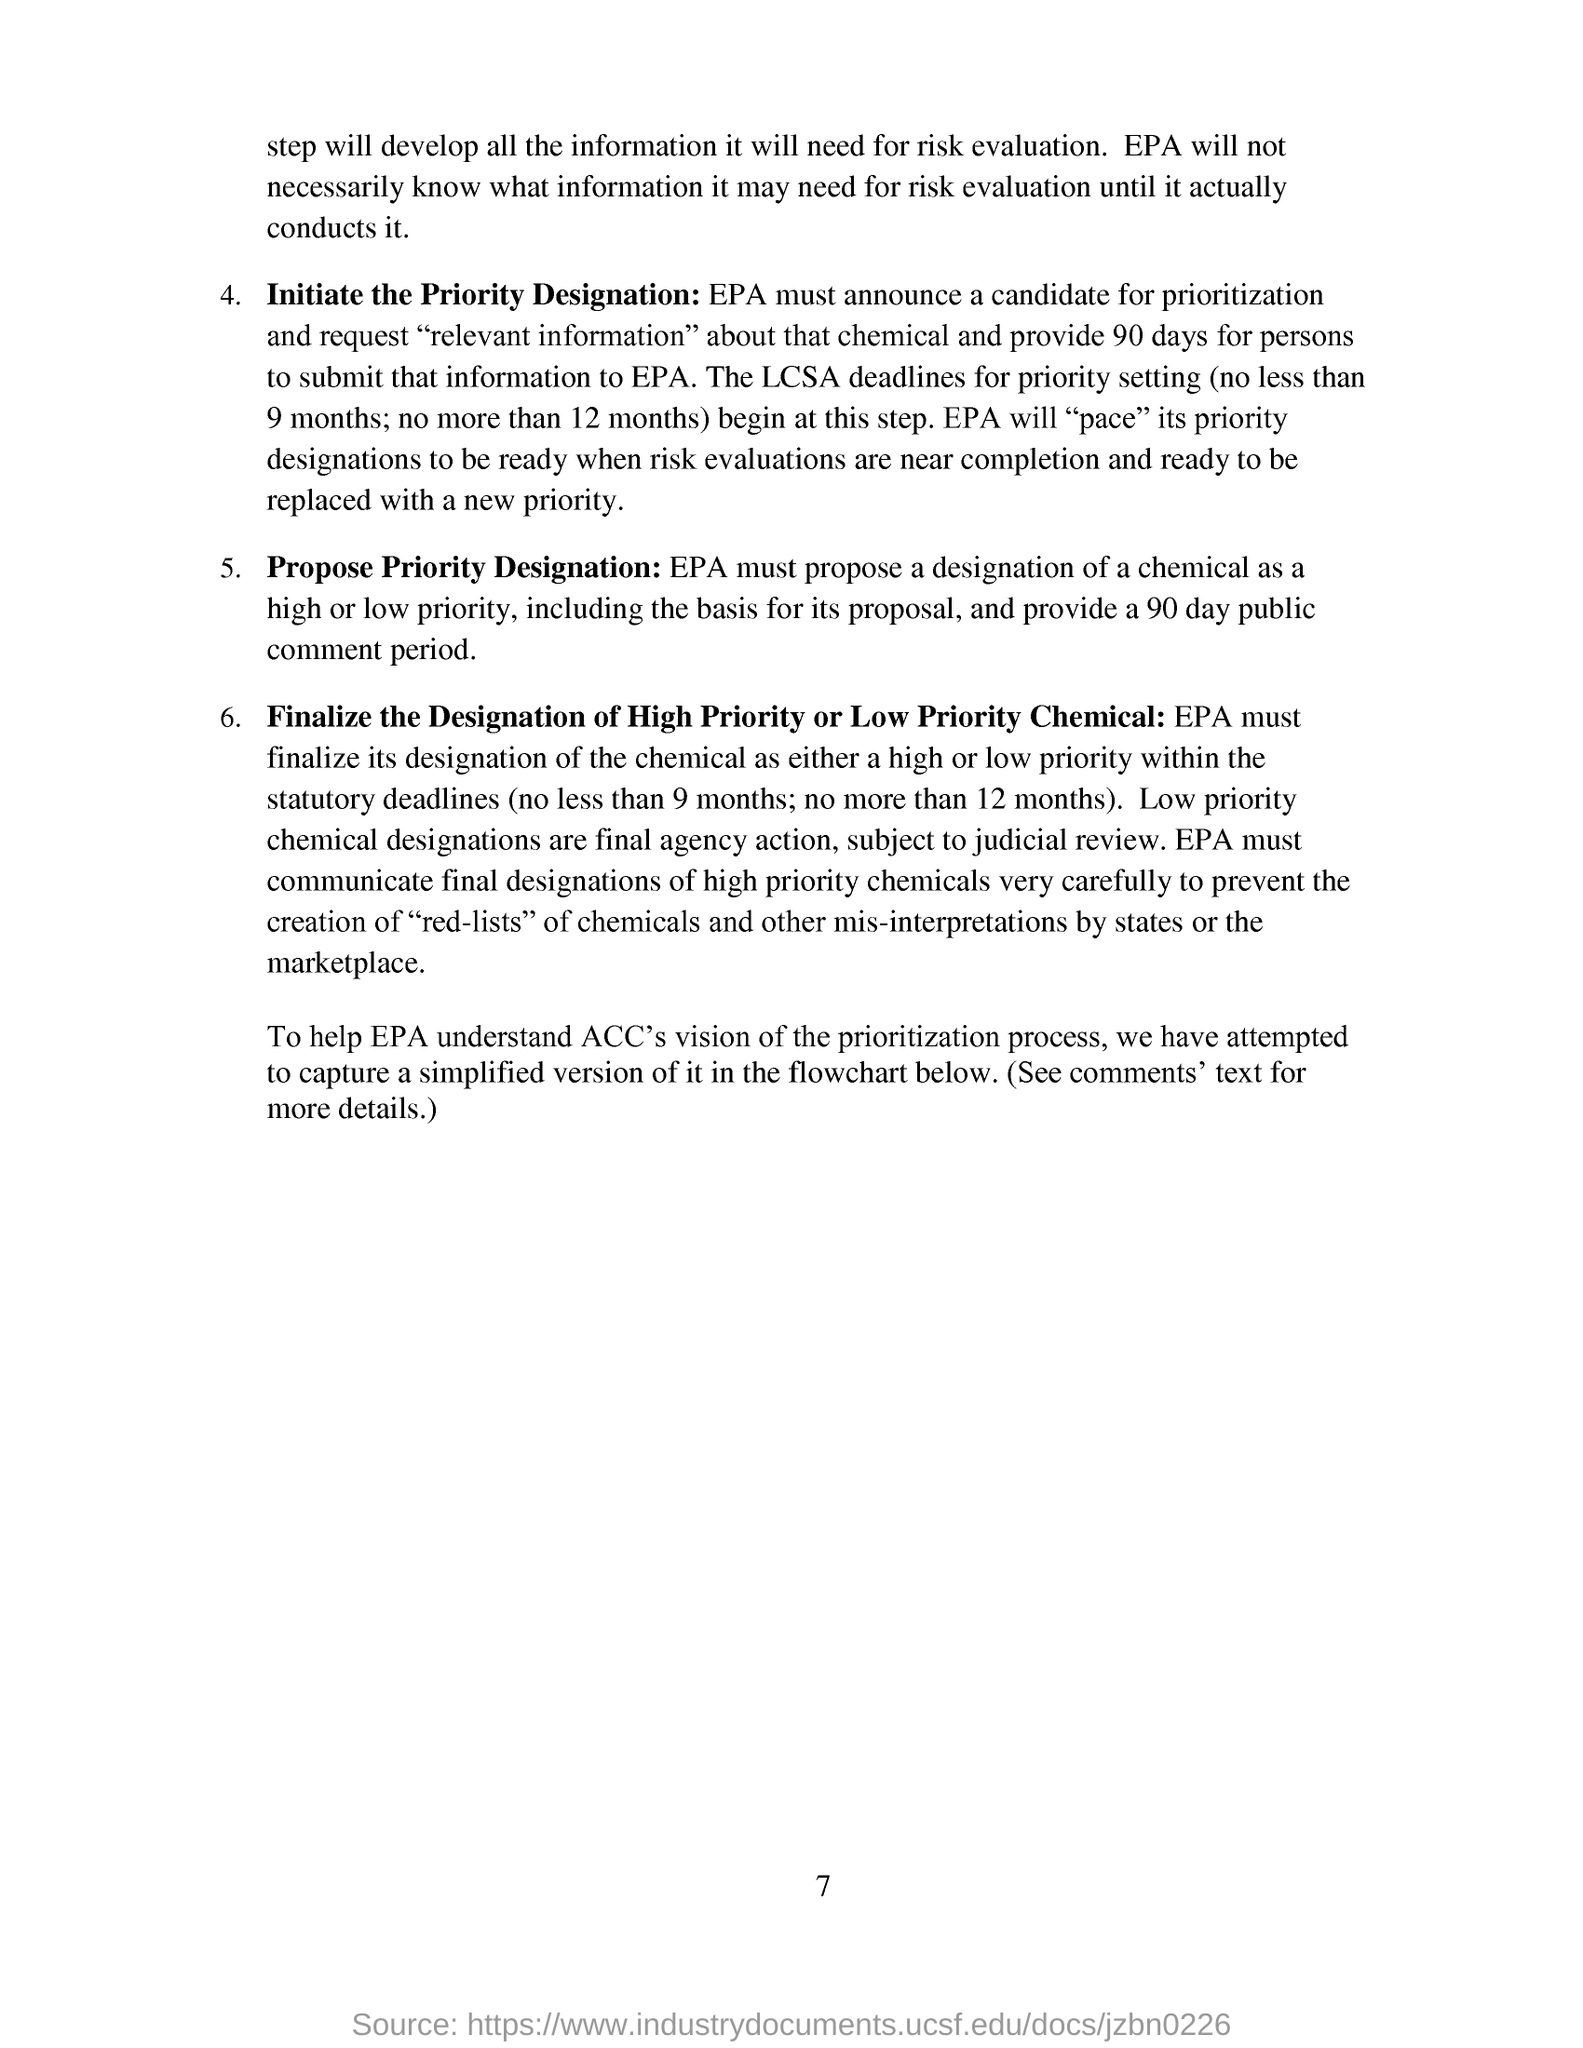How many days are the people granted to submit relevant information about that chemical?
Your answer should be compact. 90 days. Who must propose a designation of a chemical as a high or low priority?
Provide a short and direct response. EPA. Who initiates priority designation?
Your answer should be very brief. EPA. How long is the public comment period?
Give a very brief answer. 90 day public comment period. 